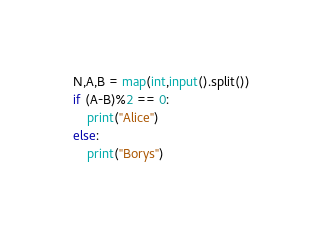Convert code to text. <code><loc_0><loc_0><loc_500><loc_500><_Python_>N,A,B = map(int,input().split())
if (A-B)%2 == 0:
    print("Alice")
else:
    print("Borys")</code> 